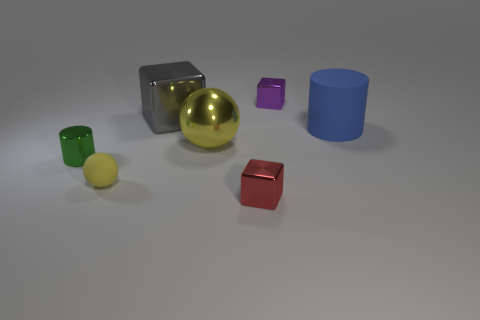There is a tiny object behind the tiny shiny thing that is left of the tiny yellow matte sphere; are there any large blue cylinders to the right of it?
Provide a short and direct response. Yes. There is a metal block that is on the right side of the shiny block that is in front of the rubber thing on the left side of the purple cube; what is its color?
Offer a terse response. Purple. What material is the small thing that is the same shape as the big yellow shiny thing?
Provide a short and direct response. Rubber. There is a matte thing that is to the left of the cube in front of the large blue cylinder; how big is it?
Make the answer very short. Small. What is the big sphere right of the small green shiny cylinder made of?
Your response must be concise. Metal. There is a yellow thing that is the same material as the large gray block; what is its size?
Keep it short and to the point. Large. What number of yellow objects are the same shape as the small purple thing?
Provide a short and direct response. 0. Is the shape of the large gray object the same as the tiny thing that is in front of the small sphere?
Ensure brevity in your answer.  Yes. Is there a big green cylinder made of the same material as the small yellow sphere?
Your answer should be very brief. No. What is the material of the tiny cube behind the yellow metallic sphere in front of the rubber cylinder?
Your answer should be compact. Metal. 